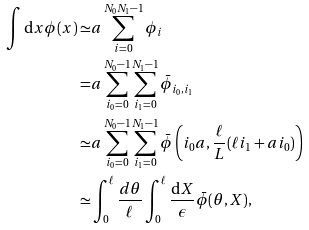Convert formula to latex. <formula><loc_0><loc_0><loc_500><loc_500>\int { \mathrm d } x \phi ( x ) \simeq & a \sum _ { i = 0 } ^ { N _ { 0 } N _ { 1 } - 1 } \phi _ { i } \\ = & a \sum _ { i _ { 0 } = 0 } ^ { N _ { 0 } - 1 } \sum _ { i _ { 1 } = 0 } ^ { N _ { 1 } - 1 } \bar { \phi } _ { i _ { 0 } , i _ { 1 } } \\ \simeq & a \sum _ { i _ { 0 } = 0 } ^ { N _ { 0 } - 1 } \sum _ { i _ { 1 } = 0 } ^ { N _ { 1 } - 1 } \bar { \phi } \left ( i _ { 0 } a , \frac { \ell } { L } ( \ell i _ { 1 } + a i _ { 0 } ) \right ) \\ \simeq & \int _ { 0 } ^ { \ell } \frac { d \theta } { \ell } \int _ { 0 } ^ { \ell } \frac { { \mathrm d } X } { \epsilon } \bar { \phi } ( \theta , X ) ,</formula> 